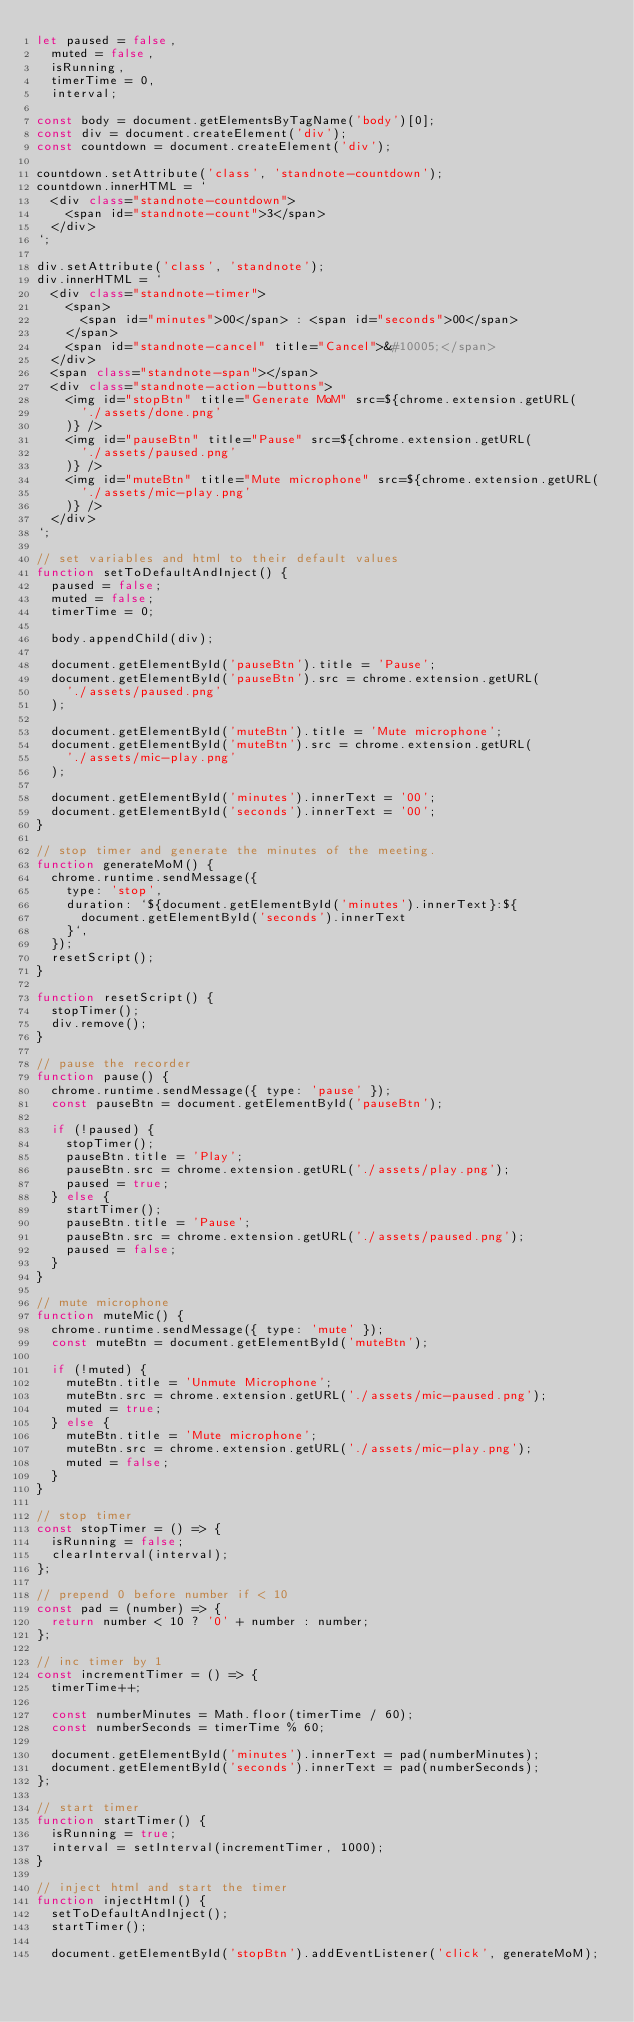Convert code to text. <code><loc_0><loc_0><loc_500><loc_500><_JavaScript_>let paused = false,
  muted = false,
  isRunning,
  timerTime = 0,
  interval;

const body = document.getElementsByTagName('body')[0];
const div = document.createElement('div');
const countdown = document.createElement('div');

countdown.setAttribute('class', 'standnote-countdown');
countdown.innerHTML = `
  <div class="standnote-countdown">
    <span id="standnote-count">3</span>
  </div>
`;

div.setAttribute('class', 'standnote');
div.innerHTML = `
  <div class="standnote-timer">
    <span>
      <span id="minutes">00</span> : <span id="seconds">00</span>
    </span>
    <span id="standnote-cancel" title="Cancel">&#10005;</span>
  </div>
  <span class="standnote-span"></span>
  <div class="standnote-action-buttons">
    <img id="stopBtn" title="Generate MoM" src=${chrome.extension.getURL(
      './assets/done.png'
    )} />
    <img id="pauseBtn" title="Pause" src=${chrome.extension.getURL(
      './assets/paused.png'
    )} />
    <img id="muteBtn" title="Mute microphone" src=${chrome.extension.getURL(
      './assets/mic-play.png'
    )} />
  </div>
`;

// set variables and html to their default values
function setToDefaultAndInject() {
  paused = false;
  muted = false;
  timerTime = 0;

  body.appendChild(div);

  document.getElementById('pauseBtn').title = 'Pause';
  document.getElementById('pauseBtn').src = chrome.extension.getURL(
    './assets/paused.png'
  );

  document.getElementById('muteBtn').title = 'Mute microphone';
  document.getElementById('muteBtn').src = chrome.extension.getURL(
    './assets/mic-play.png'
  );

  document.getElementById('minutes').innerText = '00';
  document.getElementById('seconds').innerText = '00';
}

// stop timer and generate the minutes of the meeting.
function generateMoM() {
  chrome.runtime.sendMessage({
    type: 'stop',
    duration: `${document.getElementById('minutes').innerText}:${
      document.getElementById('seconds').innerText
    }`,
  });
  resetScript();
}

function resetScript() {
  stopTimer();
  div.remove();
}

// pause the recorder
function pause() {
  chrome.runtime.sendMessage({ type: 'pause' });
  const pauseBtn = document.getElementById('pauseBtn');

  if (!paused) {
    stopTimer();
    pauseBtn.title = 'Play';
    pauseBtn.src = chrome.extension.getURL('./assets/play.png');
    paused = true;
  } else {
    startTimer();
    pauseBtn.title = 'Pause';
    pauseBtn.src = chrome.extension.getURL('./assets/paused.png');
    paused = false;
  }
}

// mute microphone
function muteMic() {
  chrome.runtime.sendMessage({ type: 'mute' });
  const muteBtn = document.getElementById('muteBtn');

  if (!muted) {
    muteBtn.title = 'Unmute Microphone';
    muteBtn.src = chrome.extension.getURL('./assets/mic-paused.png');
    muted = true;
  } else {
    muteBtn.title = 'Mute microphone';
    muteBtn.src = chrome.extension.getURL('./assets/mic-play.png');
    muted = false;
  }
}

// stop timer
const stopTimer = () => {
  isRunning = false;
  clearInterval(interval);
};

// prepend 0 before number if < 10
const pad = (number) => {
  return number < 10 ? '0' + number : number;
};

// inc timer by 1
const incrementTimer = () => {
  timerTime++;

  const numberMinutes = Math.floor(timerTime / 60);
  const numberSeconds = timerTime % 60;

  document.getElementById('minutes').innerText = pad(numberMinutes);
  document.getElementById('seconds').innerText = pad(numberSeconds);
};

// start timer
function startTimer() {
  isRunning = true;
  interval = setInterval(incrementTimer, 1000);
}

// inject html and start the timer
function injectHtml() {
  setToDefaultAndInject();
  startTimer();

  document.getElementById('stopBtn').addEventListener('click', generateMoM);</code> 